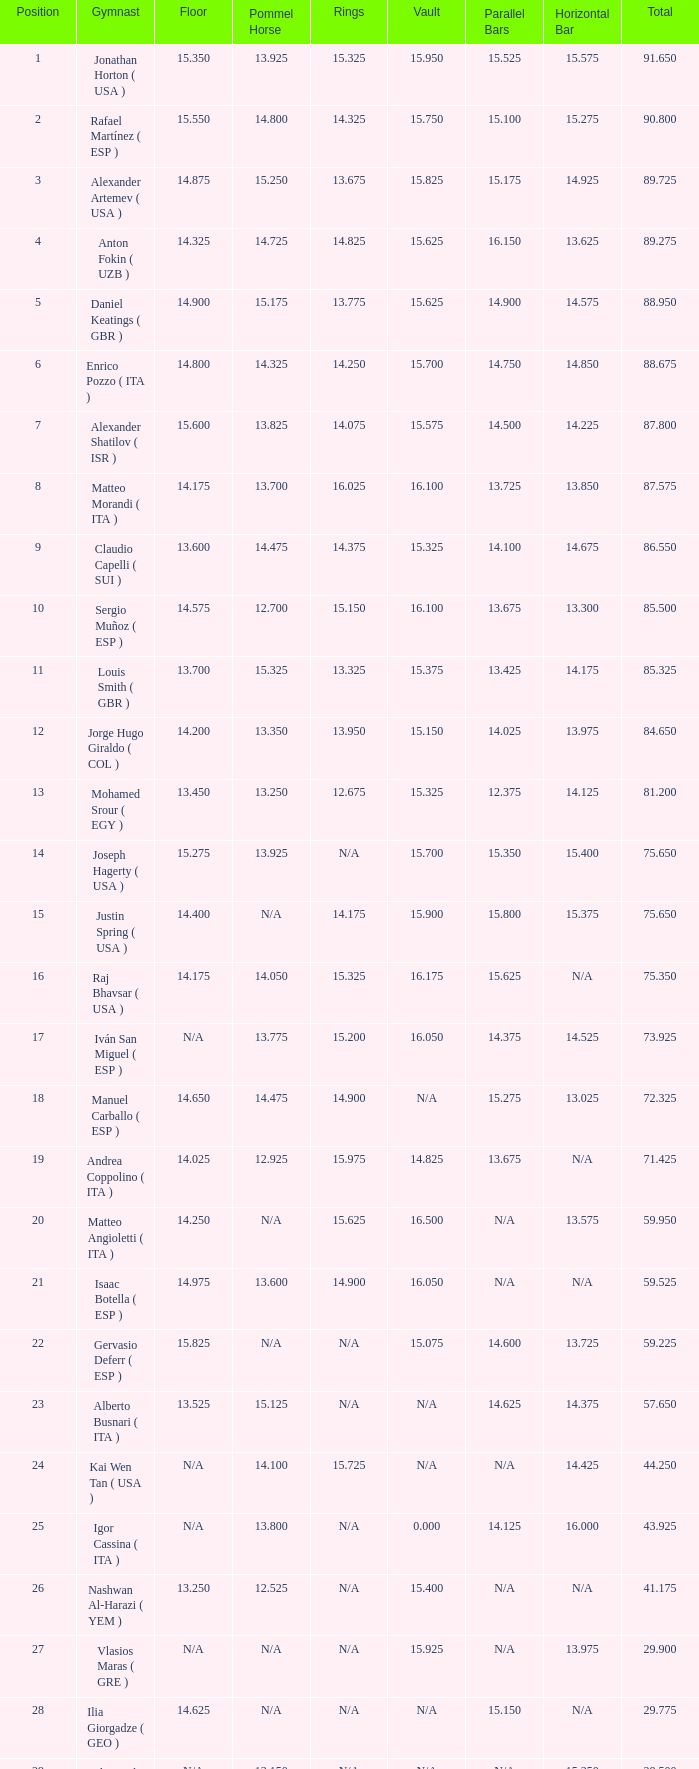Could you parse the entire table? {'header': ['Position', 'Gymnast', 'Floor', 'Pommel Horse', 'Rings', 'Vault', 'Parallel Bars', 'Horizontal Bar', 'Total'], 'rows': [['1', 'Jonathan Horton ( USA )', '15.350', '13.925', '15.325', '15.950', '15.525', '15.575', '91.650'], ['2', 'Rafael Martínez ( ESP )', '15.550', '14.800', '14.325', '15.750', '15.100', '15.275', '90.800'], ['3', 'Alexander Artemev ( USA )', '14.875', '15.250', '13.675', '15.825', '15.175', '14.925', '89.725'], ['4', 'Anton Fokin ( UZB )', '14.325', '14.725', '14.825', '15.625', '16.150', '13.625', '89.275'], ['5', 'Daniel Keatings ( GBR )', '14.900', '15.175', '13.775', '15.625', '14.900', '14.575', '88.950'], ['6', 'Enrico Pozzo ( ITA )', '14.800', '14.325', '14.250', '15.700', '14.750', '14.850', '88.675'], ['7', 'Alexander Shatilov ( ISR )', '15.600', '13.825', '14.075', '15.575', '14.500', '14.225', '87.800'], ['8', 'Matteo Morandi ( ITA )', '14.175', '13.700', '16.025', '16.100', '13.725', '13.850', '87.575'], ['9', 'Claudio Capelli ( SUI )', '13.600', '14.475', '14.375', '15.325', '14.100', '14.675', '86.550'], ['10', 'Sergio Muñoz ( ESP )', '14.575', '12.700', '15.150', '16.100', '13.675', '13.300', '85.500'], ['11', 'Louis Smith ( GBR )', '13.700', '15.325', '13.325', '15.375', '13.425', '14.175', '85.325'], ['12', 'Jorge Hugo Giraldo ( COL )', '14.200', '13.350', '13.950', '15.150', '14.025', '13.975', '84.650'], ['13', 'Mohamed Srour ( EGY )', '13.450', '13.250', '12.675', '15.325', '12.375', '14.125', '81.200'], ['14', 'Joseph Hagerty ( USA )', '15.275', '13.925', 'N/A', '15.700', '15.350', '15.400', '75.650'], ['15', 'Justin Spring ( USA )', '14.400', 'N/A', '14.175', '15.900', '15.800', '15.375', '75.650'], ['16', 'Raj Bhavsar ( USA )', '14.175', '14.050', '15.325', '16.175', '15.625', 'N/A', '75.350'], ['17', 'Iván San Miguel ( ESP )', 'N/A', '13.775', '15.200', '16.050', '14.375', '14.525', '73.925'], ['18', 'Manuel Carballo ( ESP )', '14.650', '14.475', '14.900', 'N/A', '15.275', '13.025', '72.325'], ['19', 'Andrea Coppolino ( ITA )', '14.025', '12.925', '15.975', '14.825', '13.675', 'N/A', '71.425'], ['20', 'Matteo Angioletti ( ITA )', '14.250', 'N/A', '15.625', '16.500', 'N/A', '13.575', '59.950'], ['21', 'Isaac Botella ( ESP )', '14.975', '13.600', '14.900', '16.050', 'N/A', 'N/A', '59.525'], ['22', 'Gervasio Deferr ( ESP )', '15.825', 'N/A', 'N/A', '15.075', '14.600', '13.725', '59.225'], ['23', 'Alberto Busnari ( ITA )', '13.525', '15.125', 'N/A', 'N/A', '14.625', '14.375', '57.650'], ['24', 'Kai Wen Tan ( USA )', 'N/A', '14.100', '15.725', 'N/A', 'N/A', '14.425', '44.250'], ['25', 'Igor Cassina ( ITA )', 'N/A', '13.800', 'N/A', '0.000', '14.125', '16.000', '43.925'], ['26', 'Nashwan Al-Harazi ( YEM )', '13.250', '12.525', 'N/A', '15.400', 'N/A', 'N/A', '41.175'], ['27', 'Vlasios Maras ( GRE )', 'N/A', 'N/A', 'N/A', '15.925', 'N/A', '13.975', '29.900'], ['28', 'Ilia Giorgadze ( GEO )', '14.625', 'N/A', 'N/A', 'N/A', '15.150', 'N/A', '29.775'], ['29', 'Christoph Schärer ( SUI )', 'N/A', '13.150', 'N/A', 'N/A', 'N/A', '15.350', '28.500'], ['30', 'Leszek Blanik ( POL )', 'N/A', 'N/A', 'N/A', '16.700', 'N/A', 'N/A', '16.700']]} 175, what is the value for the parallel bars? 15.625. 